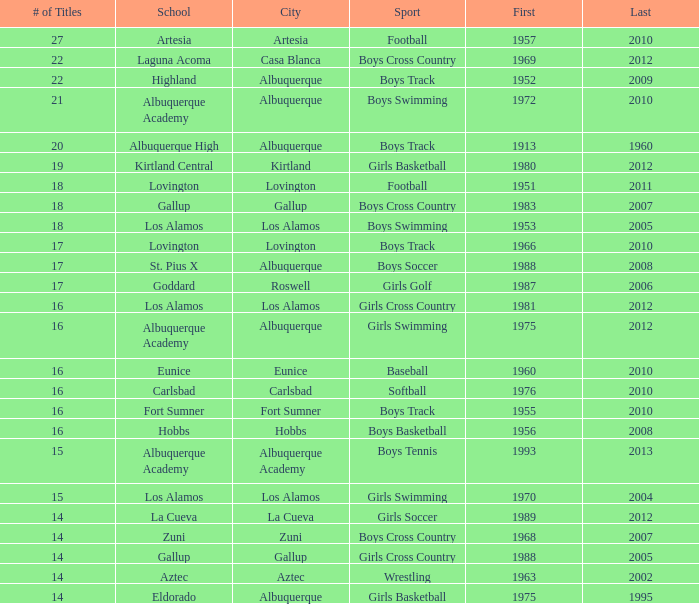What is the complete rank number for los alamos' girls cross country? 1.0. 